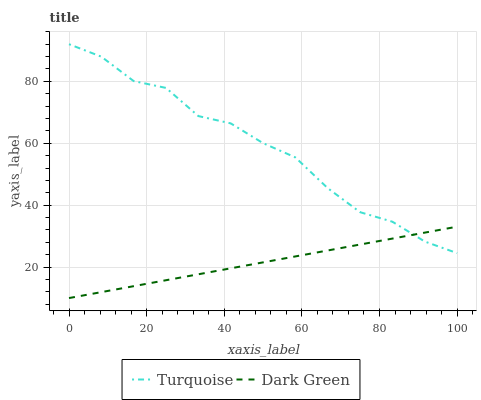Does Dark Green have the maximum area under the curve?
Answer yes or no. No. Is Dark Green the roughest?
Answer yes or no. No. Does Dark Green have the highest value?
Answer yes or no. No. 